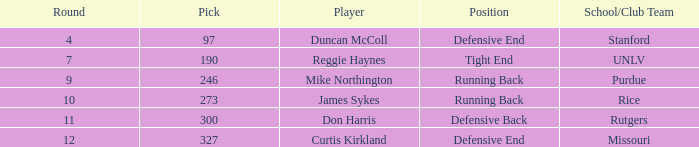What is the total number of rounds that had draft pick 97, duncan mccoll? 0.0. 